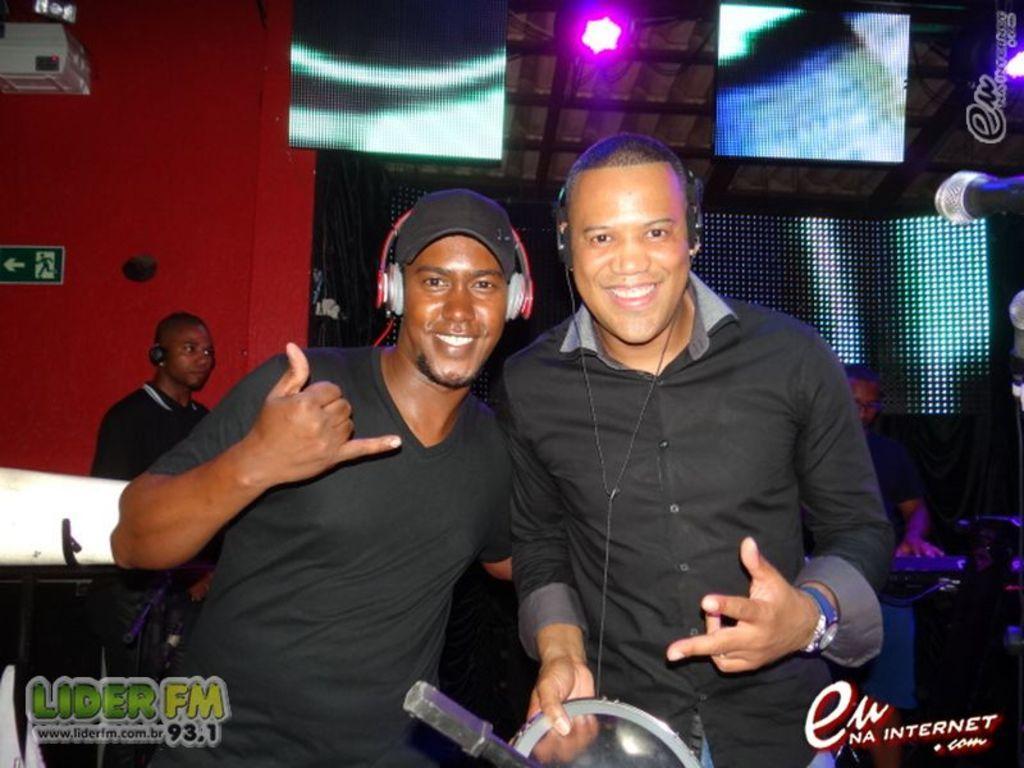Describe this image in one or two sentences. In the image I can see two people who are wearing the headphones and behind there is an other person and some lights to the wall. 